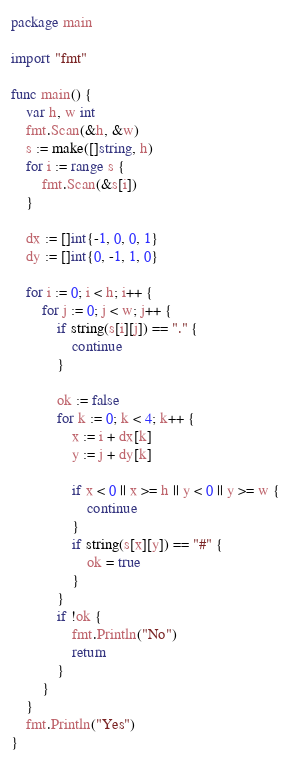Convert code to text. <code><loc_0><loc_0><loc_500><loc_500><_Go_>package main

import "fmt"

func main() {
	var h, w int
	fmt.Scan(&h, &w)
	s := make([]string, h)
	for i := range s {
		fmt.Scan(&s[i])
	}

	dx := []int{-1, 0, 0, 1}
	dy := []int{0, -1, 1, 0}

	for i := 0; i < h; i++ {
		for j := 0; j < w; j++ {
			if string(s[i][j]) == "." {
				continue
			}

			ok := false
			for k := 0; k < 4; k++ {
				x := i + dx[k]
				y := j + dy[k]

				if x < 0 || x >= h || y < 0 || y >= w {
					continue
				}
				if string(s[x][y]) == "#" {
					ok = true
				}
			}
			if !ok {
				fmt.Println("No")
				return
			}
		}
	}
	fmt.Println("Yes")
}
</code> 